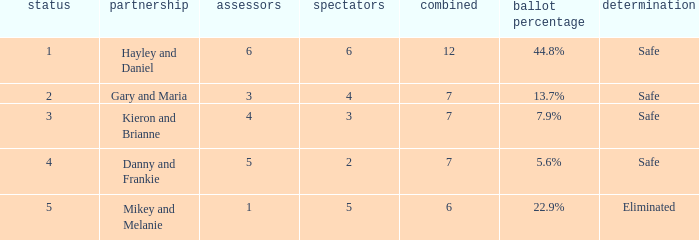Help me parse the entirety of this table. {'header': ['status', 'partnership', 'assessors', 'spectators', 'combined', 'ballot percentage', 'determination'], 'rows': [['1', 'Hayley and Daniel', '6', '6', '12', '44.8%', 'Safe'], ['2', 'Gary and Maria', '3', '4', '7', '13.7%', 'Safe'], ['3', 'Kieron and Brianne', '4', '3', '7', '7.9%', 'Safe'], ['4', 'Danny and Frankie', '5', '2', '7', '5.6%', 'Safe'], ['5', 'Mikey and Melanie', '1', '5', '6', '22.9%', 'Eliminated']]} What was the total number when the vote percentage was 44.8%? 1.0. 